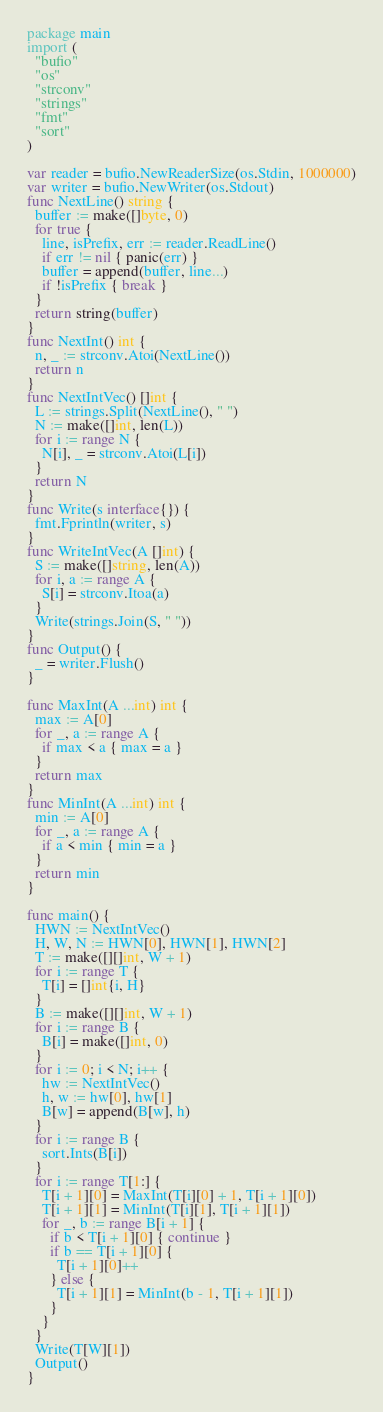Convert code to text. <code><loc_0><loc_0><loc_500><loc_500><_Go_>package main
import (
  "bufio"
  "os"
  "strconv"
  "strings"
  "fmt"
  "sort"
)

var reader = bufio.NewReaderSize(os.Stdin, 1000000)
var writer = bufio.NewWriter(os.Stdout)
func NextLine() string {
  buffer := make([]byte, 0)
  for true {
    line, isPrefix, err := reader.ReadLine()
    if err != nil { panic(err) }
    buffer = append(buffer, line...)
    if !isPrefix { break }
  }
  return string(buffer)
}
func NextInt() int {
  n, _ := strconv.Atoi(NextLine())
  return n
}
func NextIntVec() []int {
  L := strings.Split(NextLine(), " ")
  N := make([]int, len(L))
  for i := range N {
    N[i], _ = strconv.Atoi(L[i])
  }
  return N
}
func Write(s interface{}) {
  fmt.Fprintln(writer, s)
}
func WriteIntVec(A []int) {
  S := make([]string, len(A))
  for i, a := range A {
    S[i] = strconv.Itoa(a)
  }
  Write(strings.Join(S, " "))
}
func Output() {
  _ = writer.Flush()
}

func MaxInt(A ...int) int {
  max := A[0]
  for _, a := range A {
    if max < a { max = a }
  }
  return max
}
func MinInt(A ...int) int {
  min := A[0]
  for _, a := range A {
    if a < min { min = a }
  }
  return min
}

func main() {
  HWN := NextIntVec()
  H, W, N := HWN[0], HWN[1], HWN[2]
  T := make([][]int, W + 1)
  for i := range T {
    T[i] = []int{i, H}
  }
  B := make([][]int, W + 1)
  for i := range B {
    B[i] = make([]int, 0)
  }
  for i := 0; i < N; i++ {
    hw := NextIntVec()
    h, w := hw[0], hw[1]
    B[w] = append(B[w], h)
  }
  for i := range B {
    sort.Ints(B[i])
  }
  for i := range T[1:] {
    T[i + 1][0] = MaxInt(T[i][0] + 1, T[i + 1][0])
    T[i + 1][1] = MinInt(T[i][1], T[i + 1][1])
    for _, b := range B[i + 1] {
      if b < T[i + 1][0] { continue }
      if b == T[i + 1][0] {
        T[i + 1][0]++
      } else {
        T[i + 1][1] = MinInt(b - 1, T[i + 1][1])
      }
    }
  }
  Write(T[W][1])
  Output()
}</code> 